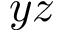<formula> <loc_0><loc_0><loc_500><loc_500>y z</formula> 